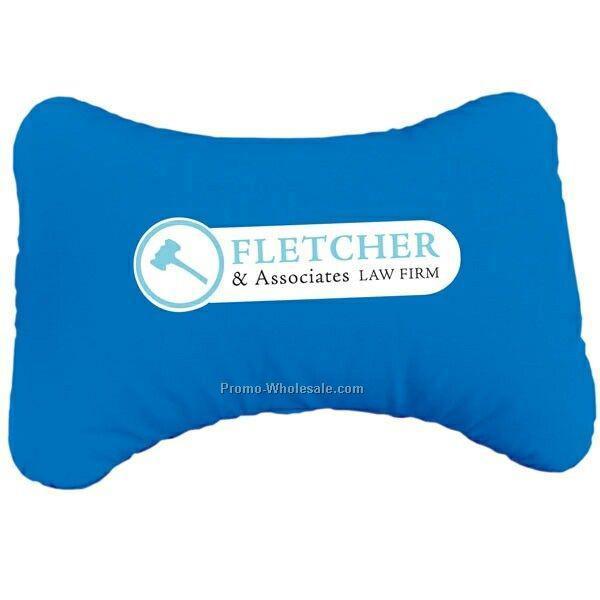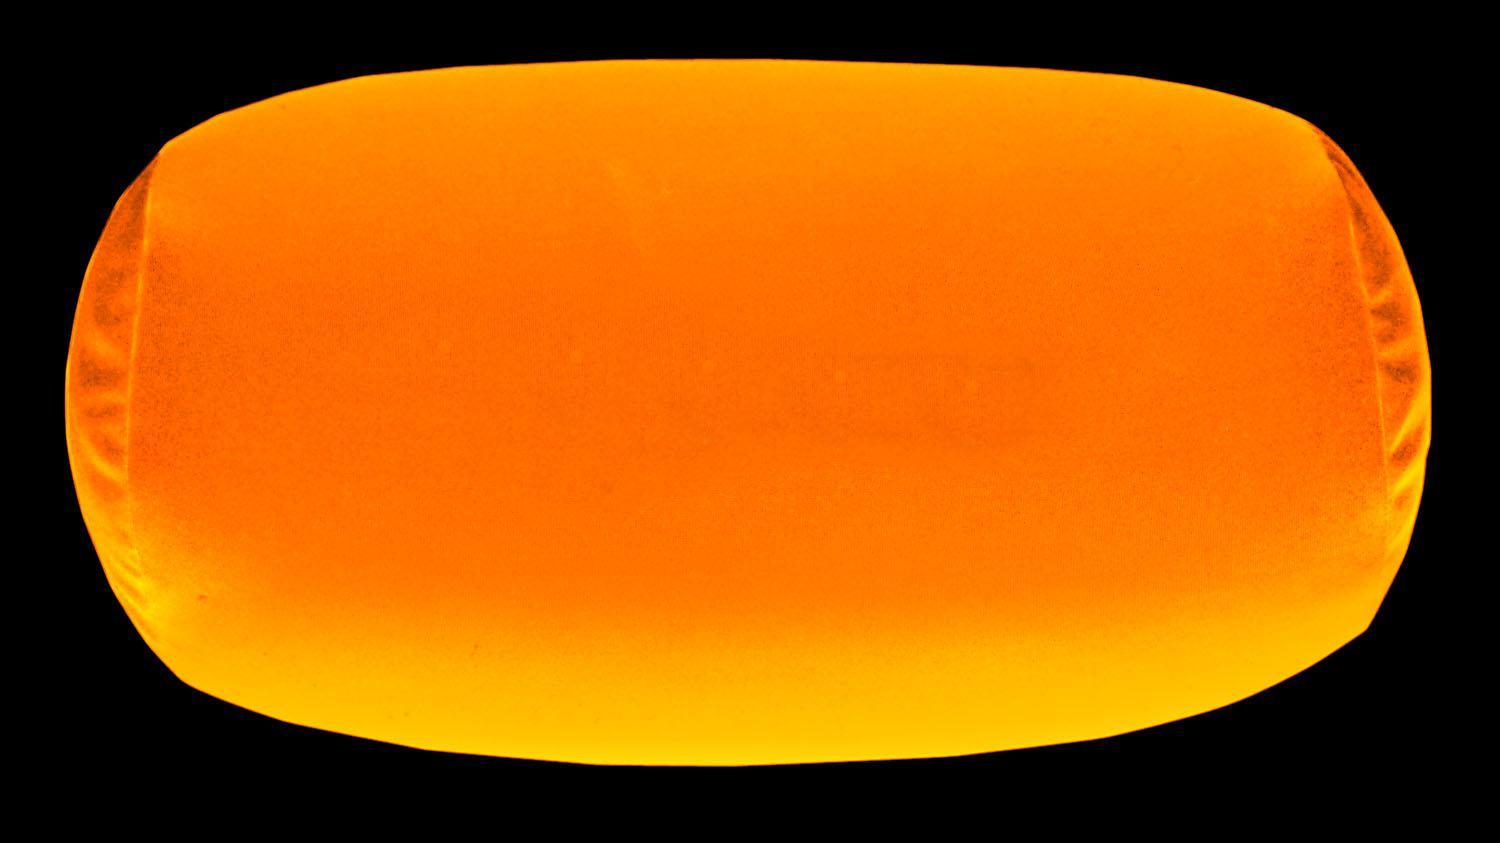The first image is the image on the left, the second image is the image on the right. For the images shown, is this caption "The left image contains one oblong blue pillow, and the right image includes a bright blue horseshoe-shaped pillow." true? Answer yes or no. No. The first image is the image on the left, the second image is the image on the right. Assess this claim about the two images: "The left image has a neck pillow in a cylindrical shape.". Correct or not? Answer yes or no. No. 